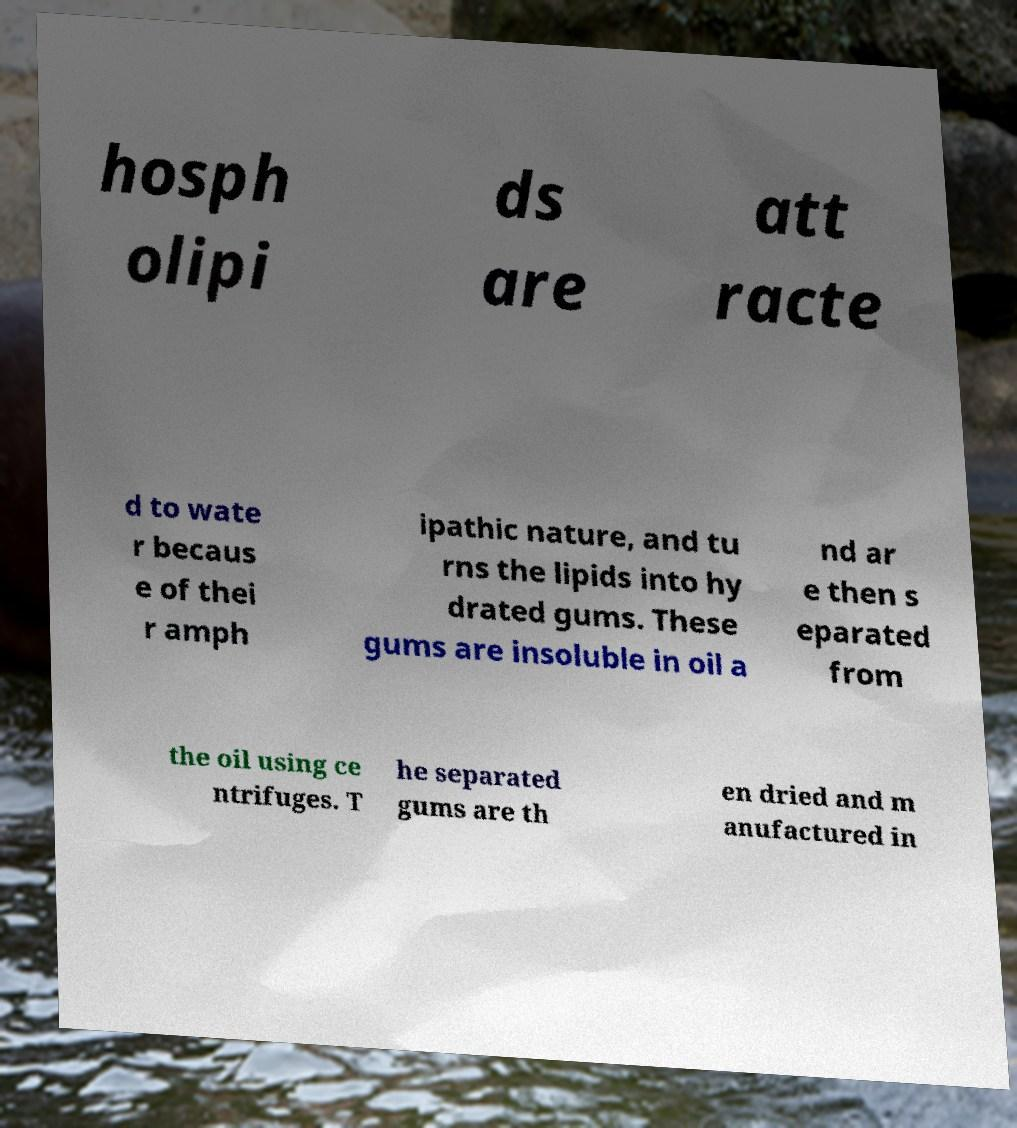There's text embedded in this image that I need extracted. Can you transcribe it verbatim? hosph olipi ds are att racte d to wate r becaus e of thei r amph ipathic nature, and tu rns the lipids into hy drated gums. These gums are insoluble in oil a nd ar e then s eparated from the oil using ce ntrifuges. T he separated gums are th en dried and m anufactured in 